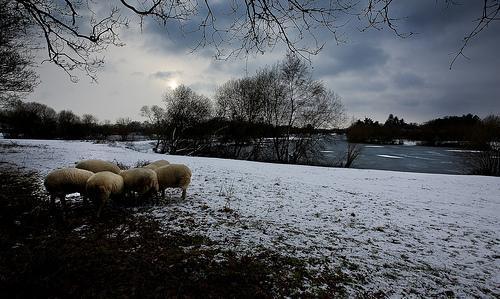How many sheep are in the picture?
Give a very brief answer. 6. 